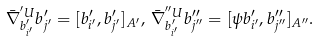<formula> <loc_0><loc_0><loc_500><loc_500>\bar { \nabla } ^ { ^ { \prime } U } _ { b ^ { \prime } _ { i ^ { \prime } } } b ^ { \prime } _ { j ^ { \prime } } = [ b ^ { \prime } _ { i ^ { \prime } } , b ^ { \prime } _ { j ^ { \prime } } ] _ { A ^ { \prime } } , \, \bar { \nabla } ^ { ^ { \prime \prime } U } _ { b ^ { \prime } _ { i ^ { \prime } } } b ^ { \prime \prime } _ { j ^ { \prime \prime } } = [ \psi b ^ { \prime } _ { i ^ { \prime } } , b ^ { \prime \prime } _ { j ^ { \prime \prime } } ] _ { A ^ { \prime \prime } } .</formula> 